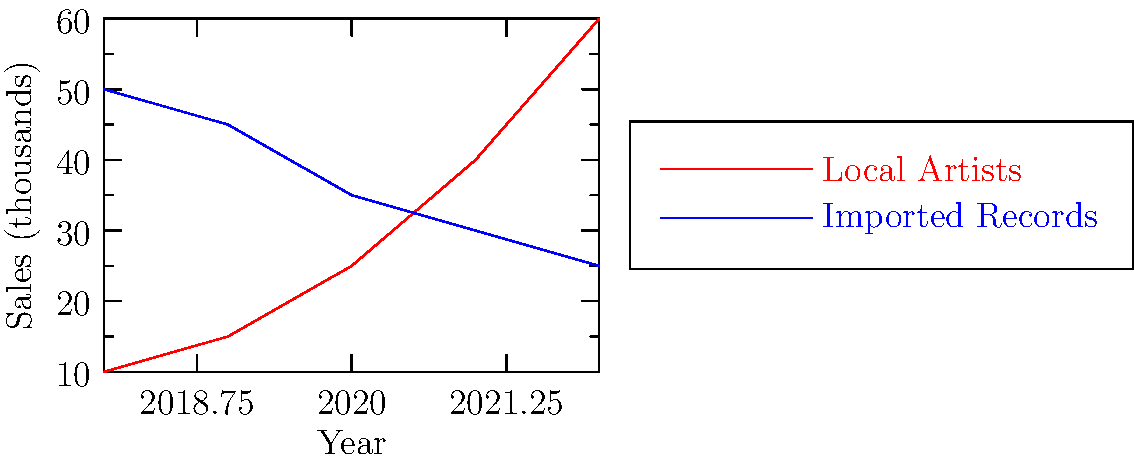Based on the line graph showing vinyl record sales trends from 2018 to 2022, in which year did sales of local artists' records surpass those of imported records? To determine when local artists' record sales surpassed imported record sales, we need to analyze the graph step-by-step:

1. The red line represents local artists' sales, while the blue line represents imported record sales.
2. We need to find the point where the red line crosses above the blue line.
3. Examining the graph from left to right:
   - In 2018: Local sales (10,000) < Imported sales (50,000)
   - In 2019: Local sales (15,000) < Imported sales (45,000)
   - In 2020: Local sales (25,000) < Imported sales (35,000)
   - In 2021: Local sales (40,000) > Imported sales (30,000)
   - In 2022: Local sales (60,000) > Imported sales (25,000)

4. We can see that the lines intersect between 2020 and 2021.
5. The crossover point occurs in 2021, as local sales (40,000) exceed imported sales (30,000) for the first time.

Therefore, 2021 is the year when sales of local artists' records surpassed those of imported records.
Answer: 2021 